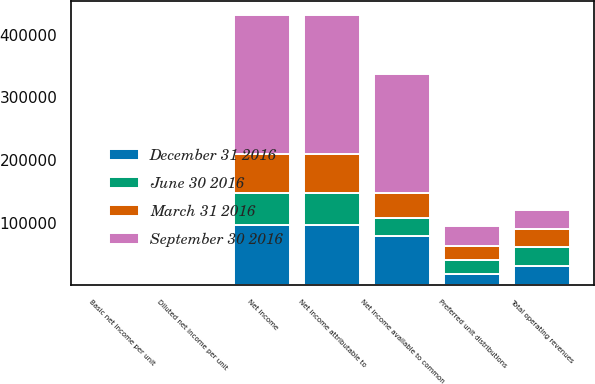Convert chart to OTSL. <chart><loc_0><loc_0><loc_500><loc_500><stacked_bar_chart><ecel><fcel>Total operating revenues<fcel>Net income<fcel>Net income attributable to<fcel>Preferred unit distributions<fcel>Net income available to common<fcel>Basic net income per unit<fcel>Diluted net income per unit<nl><fcel>December 31 2016<fcel>30133<fcel>96140<fcel>96229<fcel>17393<fcel>78836<fcel>0.49<fcel>0.49<nl><fcel>September 30 2016<fcel>30133<fcel>222435<fcel>222212<fcel>31858<fcel>190354<fcel>1.27<fcel>1.25<nl><fcel>June 30 2016<fcel>30133<fcel>50944<fcel>50832<fcel>22424<fcel>28408<fcel>0.19<fcel>0.19<nl><fcel>March 31 2016<fcel>30133<fcel>62333<fcel>62212<fcel>22424<fcel>39788<fcel>0.27<fcel>0.27<nl></chart> 